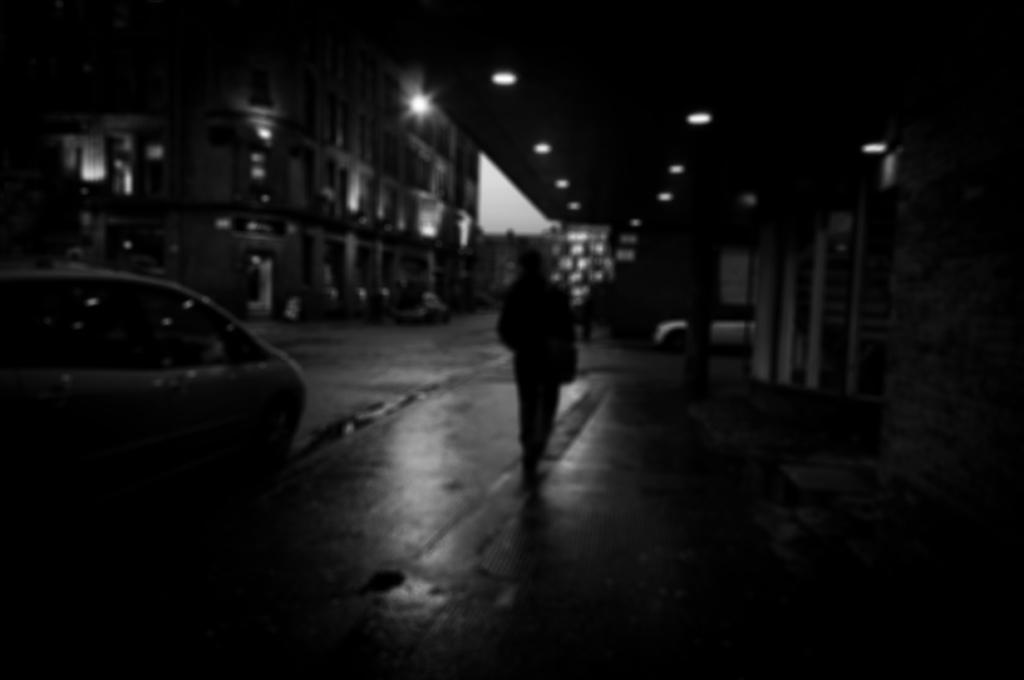What is the color scheme of the image? The image is black and white. What can be seen on the left side of the image? There is a car on the left side of the image. What is located in the middle of the image? There is a person and a building in the middle of the image. What is present at the top of the image? There are lights at the top of the image. What type of potato is being discussed by the person in the image? There is no potato present in the image, and the person's conversation is not depicted. What government policy is being debated by the person in the image? There is no indication of a government policy or debate in the image. 